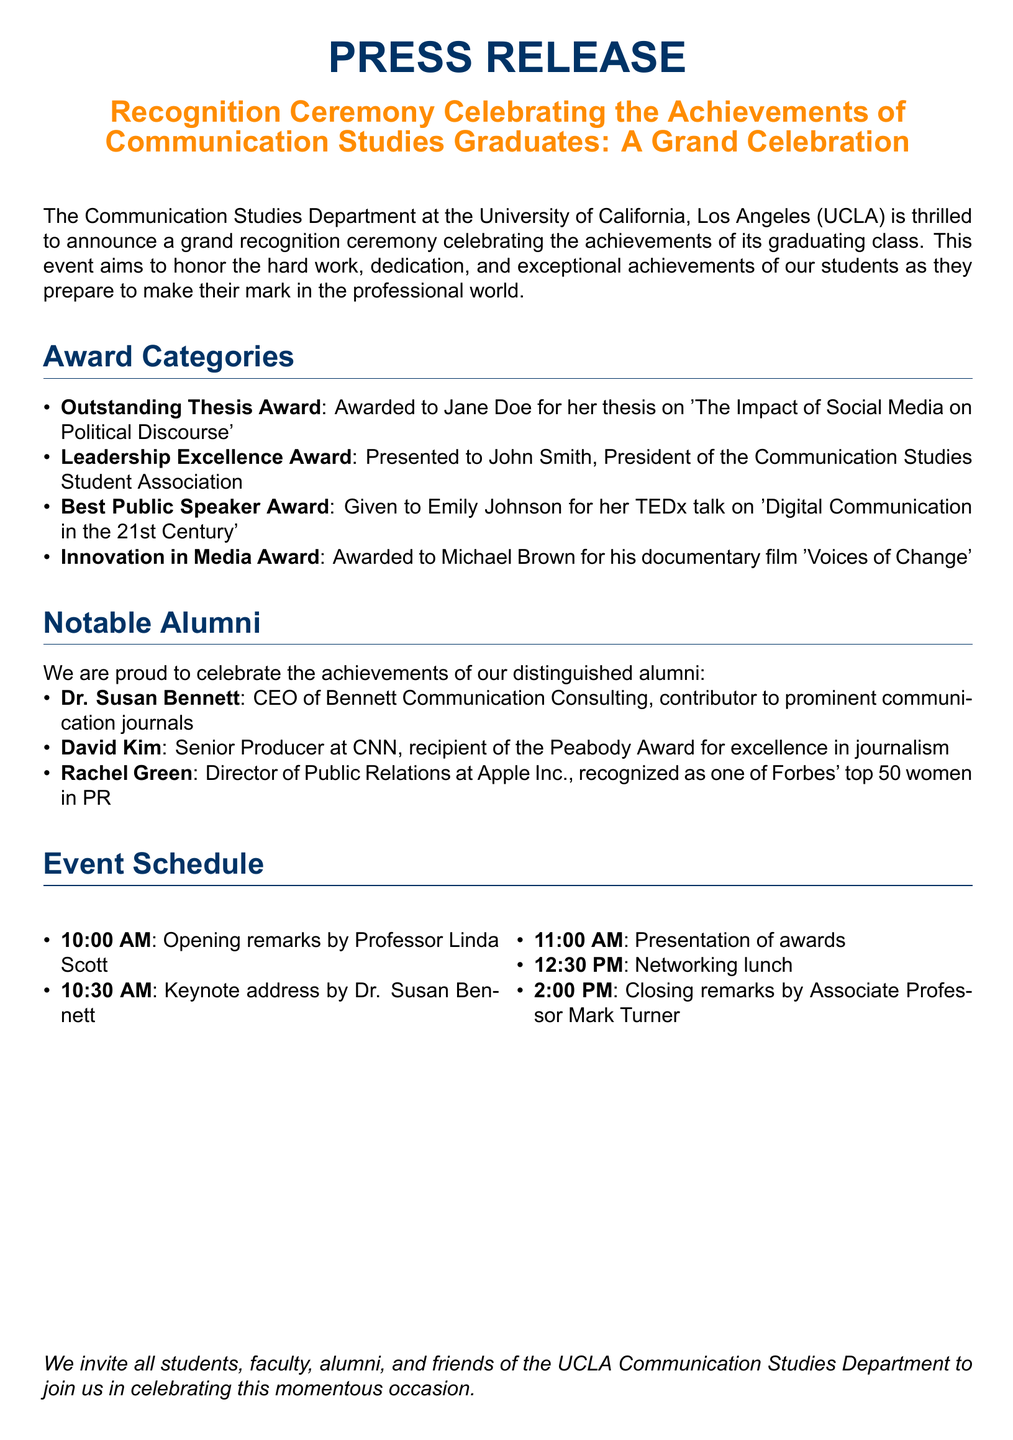What is the name of the award for the best thesis? The award for the best thesis is specifically mentioned in the document as the Outstanding Thesis Award.
Answer: Outstanding Thesis Award Who received the Leadership Excellence Award? The Leadership Excellence Award was given to John Smith, who is also noted as the President of the Communication Studies Student Association.
Answer: John Smith What time does the keynote address begin? The document outlines the event schedule, indicating that the keynote address starts at 10:30 AM.
Answer: 10:30 AM How many notable alumni are mentioned? The number of notable alumni is specified in the document, which lists three individuals.
Answer: Three What is the title of Jane Doe's thesis? The document provides the title of Jane Doe's thesis as 'The Impact of Social Media on Political Discourse.'
Answer: The Impact of Social Media on Political Discourse What event is being celebrated by the UCLA Communication Studies Department? The key event celebrated is the achievements of graduating students, as stated in the press release.
Answer: Recognition ceremony What type of awards are presented? The types of awards presented in the ceremony include Outstanding Thesis Award, Leadership Excellence Award, Best Public Speaker Award, and Innovation in Media Award.
Answer: Various awards Who is the closing speaker of the event? According to the event schedule, Associate Professor Mark Turner is listed as the closing speaker for the ceremony.
Answer: Associate Professor Mark Turner Which notable alumni is a CEO? The document mentions that Dr. Susan Bennett is the CEO of Bennett Communication Consulting.
Answer: Dr. Susan Bennett 